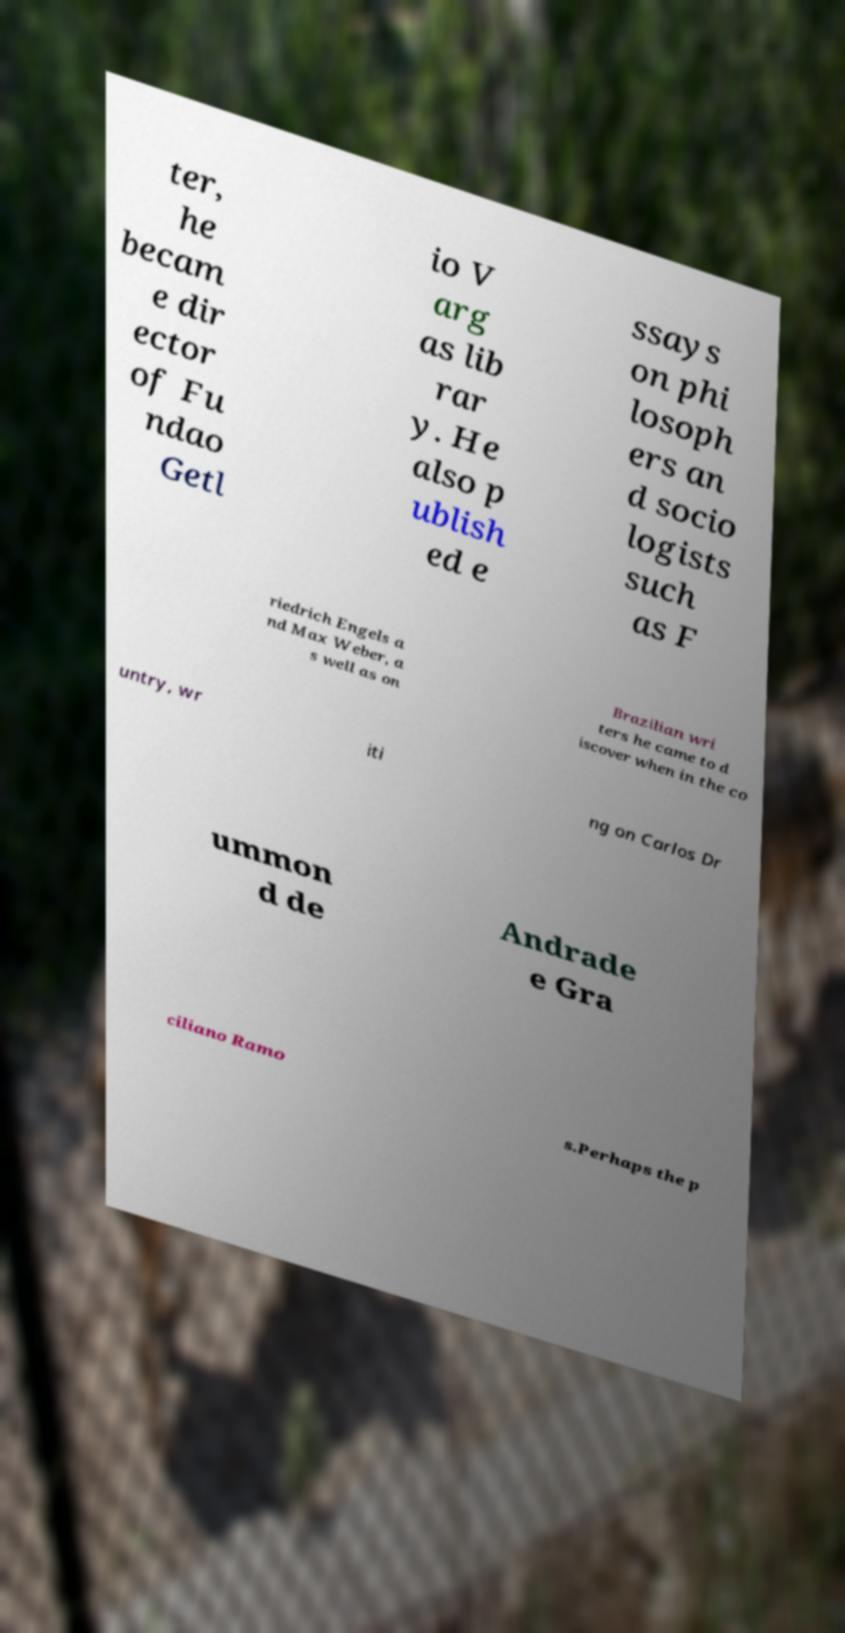Can you read and provide the text displayed in the image?This photo seems to have some interesting text. Can you extract and type it out for me? ter, he becam e dir ector of Fu ndao Getl io V arg as lib rar y. He also p ublish ed e ssays on phi losoph ers an d socio logists such as F riedrich Engels a nd Max Weber, a s well as on Brazilian wri ters he came to d iscover when in the co untry, wr iti ng on Carlos Dr ummon d de Andrade e Gra ciliano Ramo s.Perhaps the p 